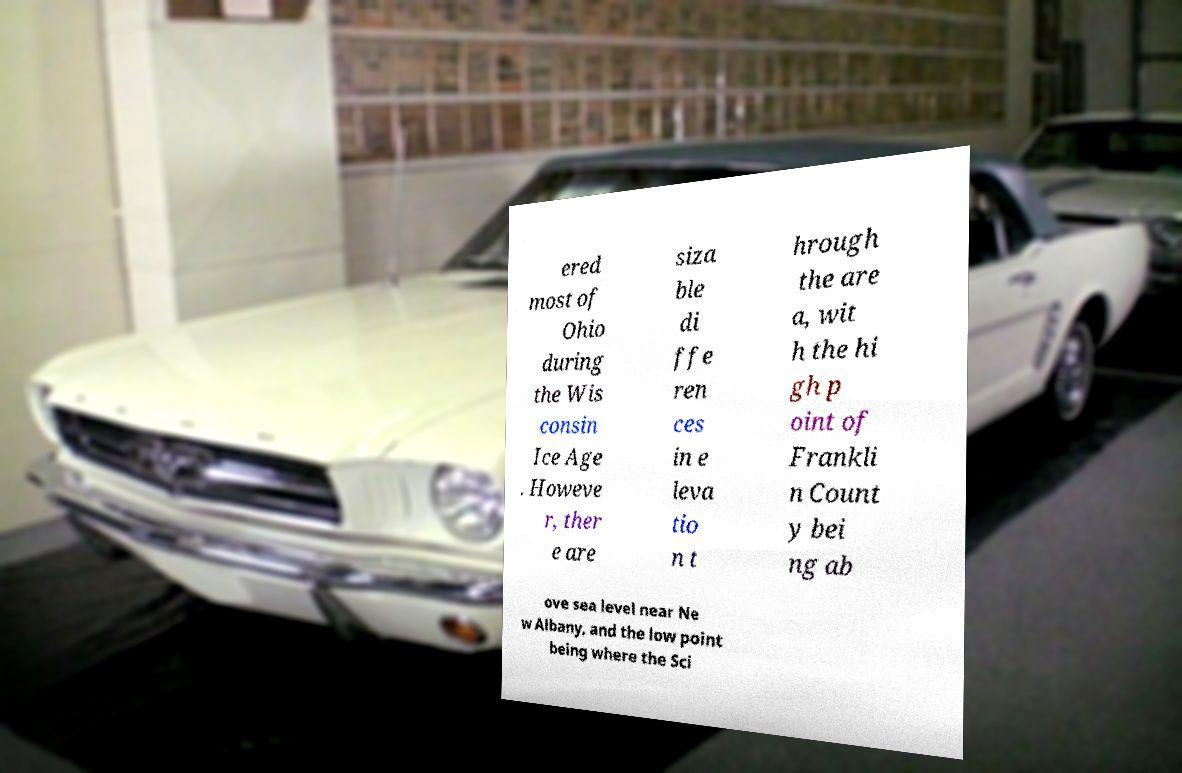Please identify and transcribe the text found in this image. ered most of Ohio during the Wis consin Ice Age . Howeve r, ther e are siza ble di ffe ren ces in e leva tio n t hrough the are a, wit h the hi gh p oint of Frankli n Count y bei ng ab ove sea level near Ne w Albany, and the low point being where the Sci 